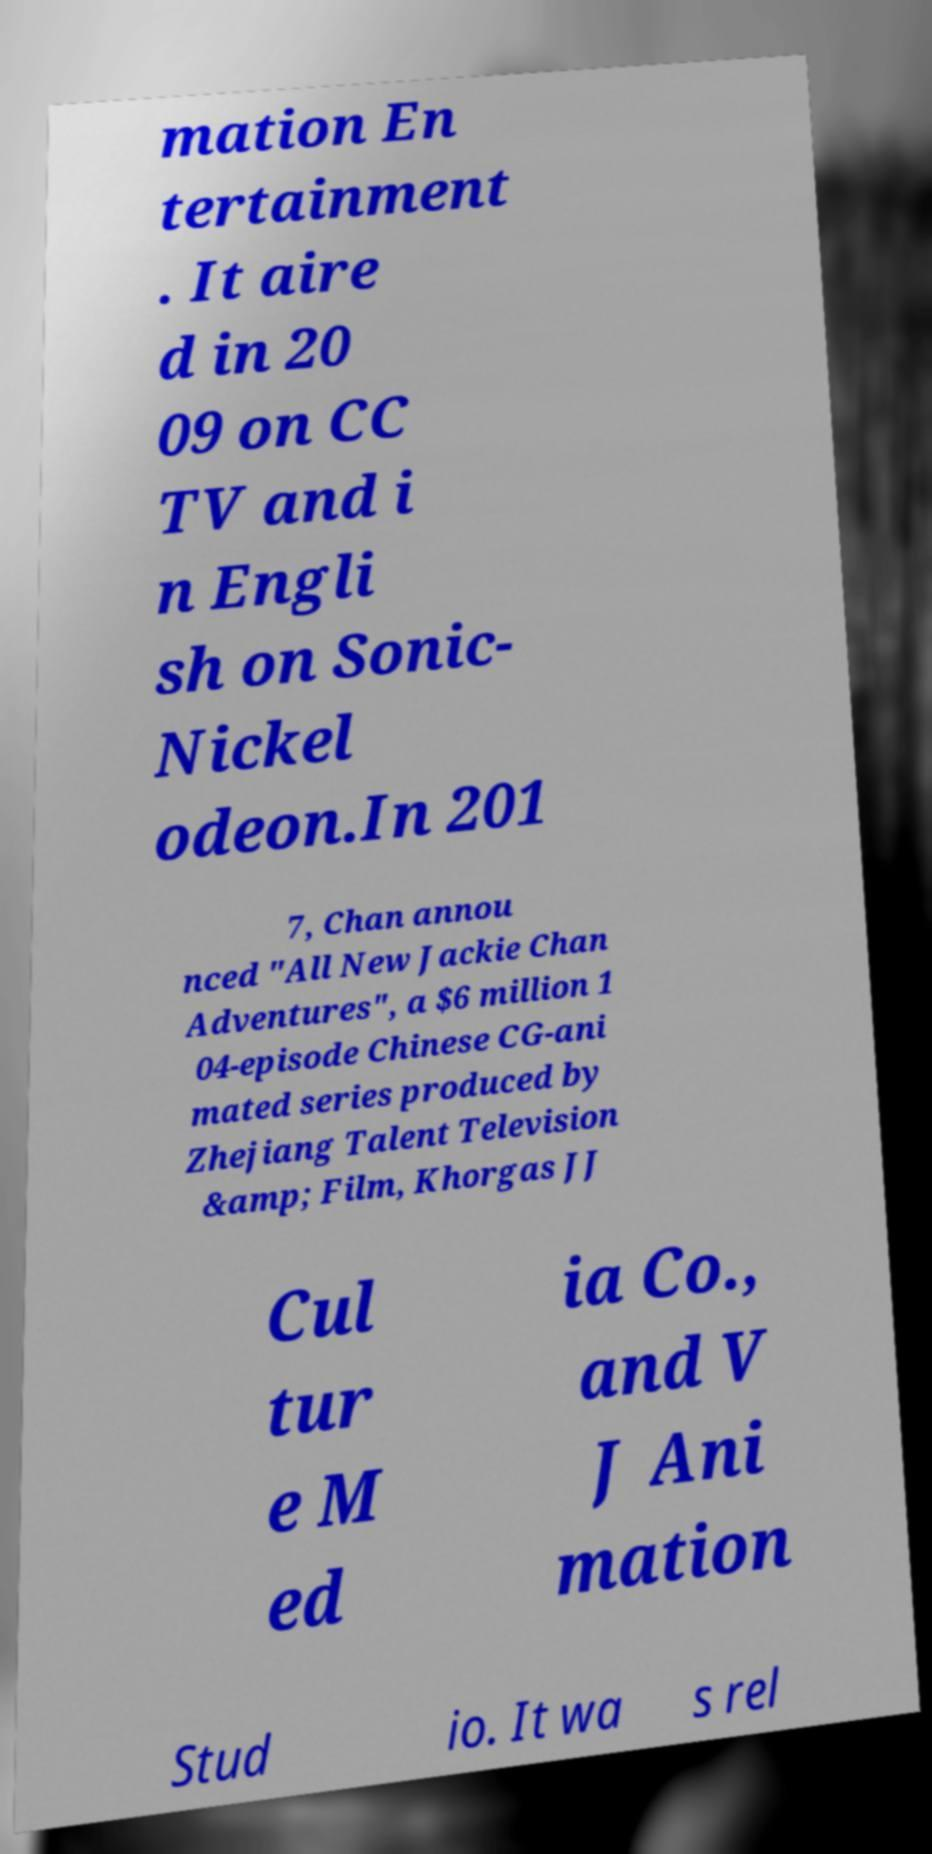What messages or text are displayed in this image? I need them in a readable, typed format. mation En tertainment . It aire d in 20 09 on CC TV and i n Engli sh on Sonic- Nickel odeon.In 201 7, Chan annou nced "All New Jackie Chan Adventures", a $6 million 1 04-episode Chinese CG-ani mated series produced by Zhejiang Talent Television &amp; Film, Khorgas JJ Cul tur e M ed ia Co., and V J Ani mation Stud io. It wa s rel 